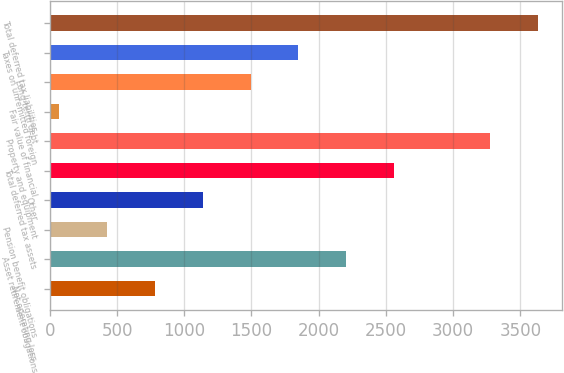Convert chart to OTSL. <chart><loc_0><loc_0><loc_500><loc_500><bar_chart><fcel>Net operating loss<fcel>Asset retirement obligations<fcel>Pension benefit obligations<fcel>Other<fcel>Total deferred tax assets<fcel>Property and equipment<fcel>Fair value of financial<fcel>Long-term debt<fcel>Taxes on unremitted foreign<fcel>Total deferred tax liabilities<nl><fcel>781.8<fcel>2205.4<fcel>425.9<fcel>1137.7<fcel>2561.3<fcel>3273.1<fcel>70<fcel>1493.6<fcel>1849.5<fcel>3629<nl></chart> 